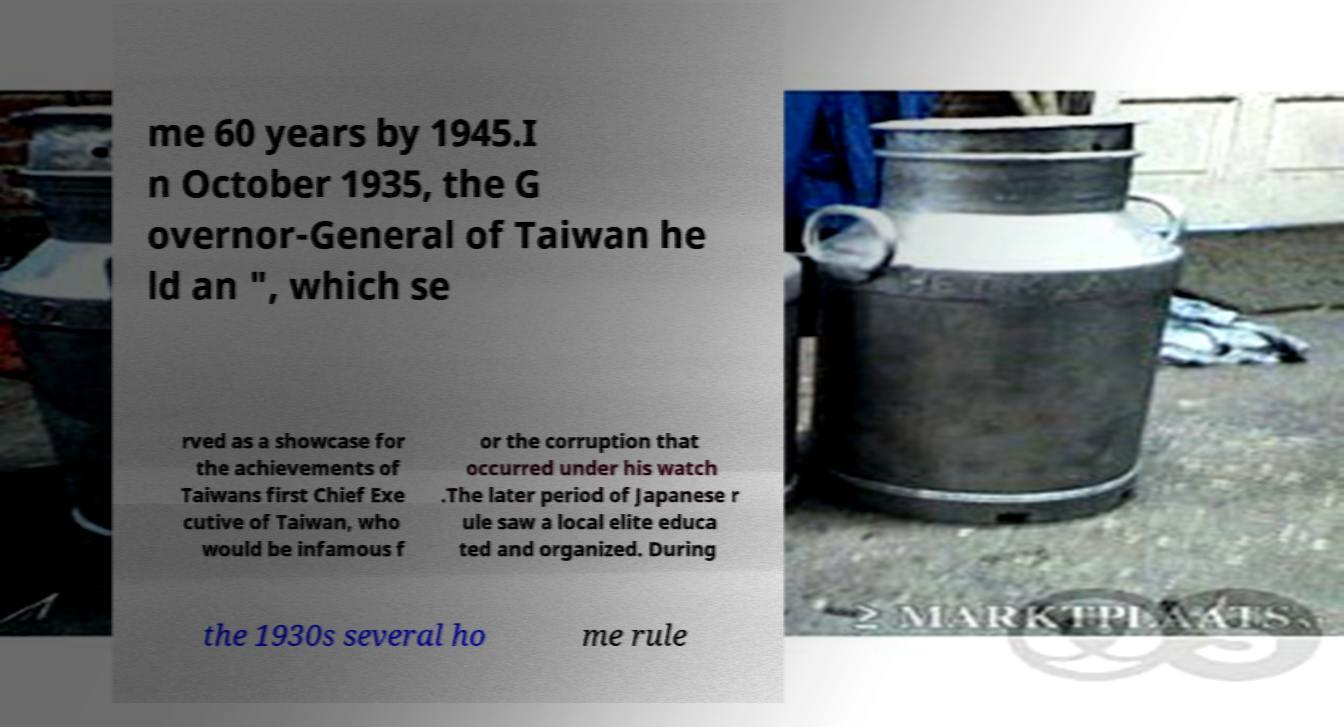Please read and relay the text visible in this image. What does it say? me 60 years by 1945.I n October 1935, the G overnor-General of Taiwan he ld an ", which se rved as a showcase for the achievements of Taiwans first Chief Exe cutive of Taiwan, who would be infamous f or the corruption that occurred under his watch .The later period of Japanese r ule saw a local elite educa ted and organized. During the 1930s several ho me rule 